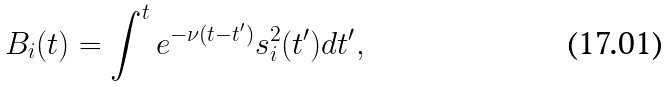<formula> <loc_0><loc_0><loc_500><loc_500>B _ { i } ( t ) = \int ^ { t } e ^ { - \nu ( t - t ^ { \prime } ) } s ^ { 2 } _ { i } ( t ^ { \prime } ) d t ^ { \prime } ,</formula> 